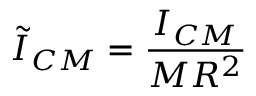<formula> <loc_0><loc_0><loc_500><loc_500>\tilde { I } _ { C M } = \frac { I _ { C M } } { M R ^ { 2 } }</formula> 